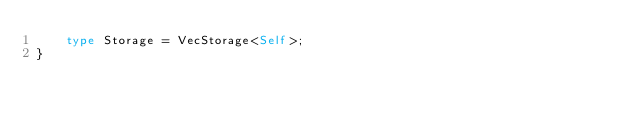Convert code to text. <code><loc_0><loc_0><loc_500><loc_500><_Rust_>    type Storage = VecStorage<Self>;
}</code> 